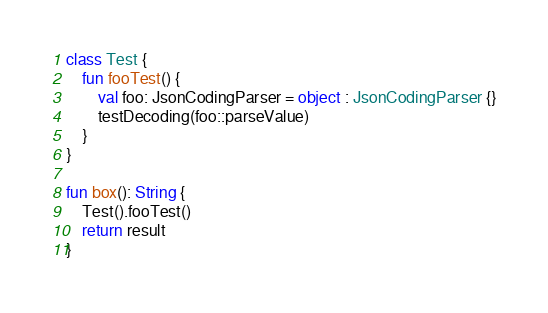Convert code to text. <code><loc_0><loc_0><loc_500><loc_500><_Kotlin_>class Test {
    fun fooTest() {
        val foo: JsonCodingParser = object : JsonCodingParser {}
        testDecoding(foo::parseValue)
    }
}

fun box(): String {
    Test().fooTest()
    return result
}</code> 